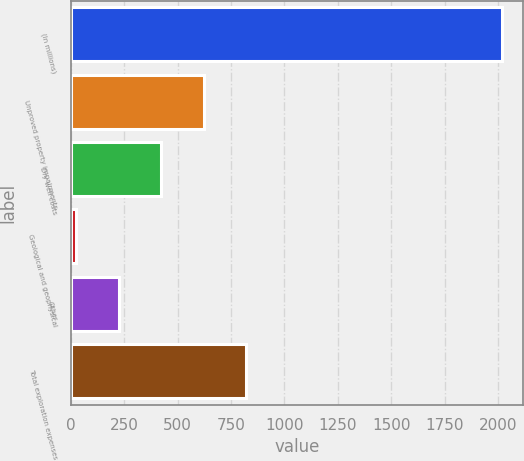Convert chart to OTSL. <chart><loc_0><loc_0><loc_500><loc_500><bar_chart><fcel>(In millions)<fcel>Unproved property impairments<fcel>Dry well costs<fcel>Geological and geophysical<fcel>Other<fcel>Total exploration expenses<nl><fcel>2017<fcel>622.6<fcel>423.4<fcel>25<fcel>224.2<fcel>821.8<nl></chart> 